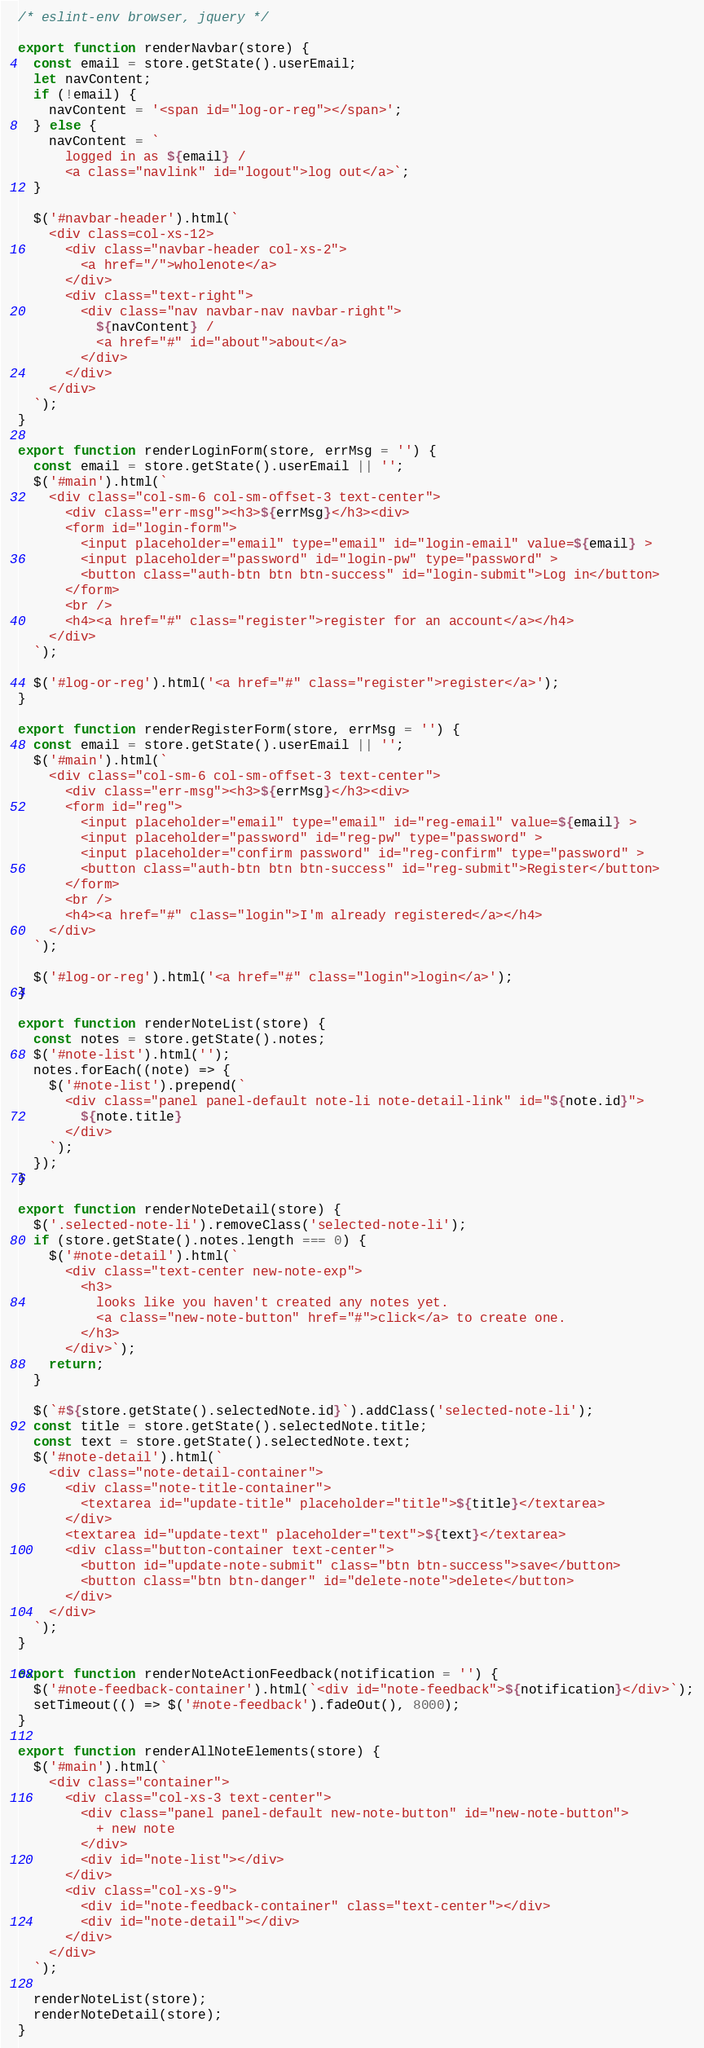<code> <loc_0><loc_0><loc_500><loc_500><_JavaScript_>/* eslint-env browser, jquery */

export function renderNavbar(store) {
  const email = store.getState().userEmail;
  let navContent;
  if (!email) {
    navContent = '<span id="log-or-reg"></span>';
  } else {
    navContent = `
      logged in as ${email} /
      <a class="navlink" id="logout">log out</a>`;
  }

  $('#navbar-header').html(`
    <div class=col-xs-12>
      <div class="navbar-header col-xs-2">
        <a href="/">wholenote</a>
      </div>
      <div class="text-right">
        <div class="nav navbar-nav navbar-right">
          ${navContent} /
          <a href="#" id="about">about</a>
        </div>
      </div>
    </div>
  `);
}

export function renderLoginForm(store, errMsg = '') {
  const email = store.getState().userEmail || '';
  $('#main').html(`
    <div class="col-sm-6 col-sm-offset-3 text-center">
      <div class="err-msg"><h3>${errMsg}</h3><div>
      <form id="login-form">
        <input placeholder="email" type="email" id="login-email" value=${email} >
        <input placeholder="password" id="login-pw" type="password" >
        <button class="auth-btn btn btn-success" id="login-submit">Log in</button>
      </form>
      <br />
      <h4><a href="#" class="register">register for an account</a></h4>
    </div>
  `);

  $('#log-or-reg').html('<a href="#" class="register">register</a>');
}

export function renderRegisterForm(store, errMsg = '') {
  const email = store.getState().userEmail || '';
  $('#main').html(`
    <div class="col-sm-6 col-sm-offset-3 text-center">
      <div class="err-msg"><h3>${errMsg}</h3><div>
      <form id="reg">
        <input placeholder="email" type="email" id="reg-email" value=${email} >
        <input placeholder="password" id="reg-pw" type="password" >
        <input placeholder="confirm password" id="reg-confirm" type="password" >
        <button class="auth-btn btn btn-success" id="reg-submit">Register</button>
      </form>
      <br />
      <h4><a href="#" class="login">I'm already registered</a></h4>
    </div>
  `);

  $('#log-or-reg').html('<a href="#" class="login">login</a>');
}

export function renderNoteList(store) {
  const notes = store.getState().notes;
  $('#note-list').html('');
  notes.forEach((note) => {
    $('#note-list').prepend(`
      <div class="panel panel-default note-li note-detail-link" id="${note.id}">
        ${note.title}
      </div>
    `);
  });
}

export function renderNoteDetail(store) {
  $('.selected-note-li').removeClass('selected-note-li');
  if (store.getState().notes.length === 0) {
    $('#note-detail').html(`
      <div class="text-center new-note-exp">
        <h3>
          looks like you haven't created any notes yet.
          <a class="new-note-button" href="#">click</a> to create one.
        </h3>
      </div>`);
    return;
  }

  $(`#${store.getState().selectedNote.id}`).addClass('selected-note-li');
  const title = store.getState().selectedNote.title;
  const text = store.getState().selectedNote.text;
  $('#note-detail').html(`
    <div class="note-detail-container">
      <div class="note-title-container">
        <textarea id="update-title" placeholder="title">${title}</textarea>
      </div>
      <textarea id="update-text" placeholder="text">${text}</textarea>
      <div class="button-container text-center">
        <button id="update-note-submit" class="btn btn-success">save</button>
        <button class="btn btn-danger" id="delete-note">delete</button>
      </div>
    </div>
  `);
}

export function renderNoteActionFeedback(notification = '') {
  $('#note-feedback-container').html(`<div id="note-feedback">${notification}</div>`);
  setTimeout(() => $('#note-feedback').fadeOut(), 8000);
}

export function renderAllNoteElements(store) {
  $('#main').html(`
    <div class="container">
      <div class="col-xs-3 text-center">
        <div class="panel panel-default new-note-button" id="new-note-button">
          + new note
        </div>
        <div id="note-list"></div>
      </div>
      <div class="col-xs-9">
        <div id="note-feedback-container" class="text-center"></div>
        <div id="note-detail"></div>
      </div>
    </div>
  `);

  renderNoteList(store);
  renderNoteDetail(store);
}
</code> 